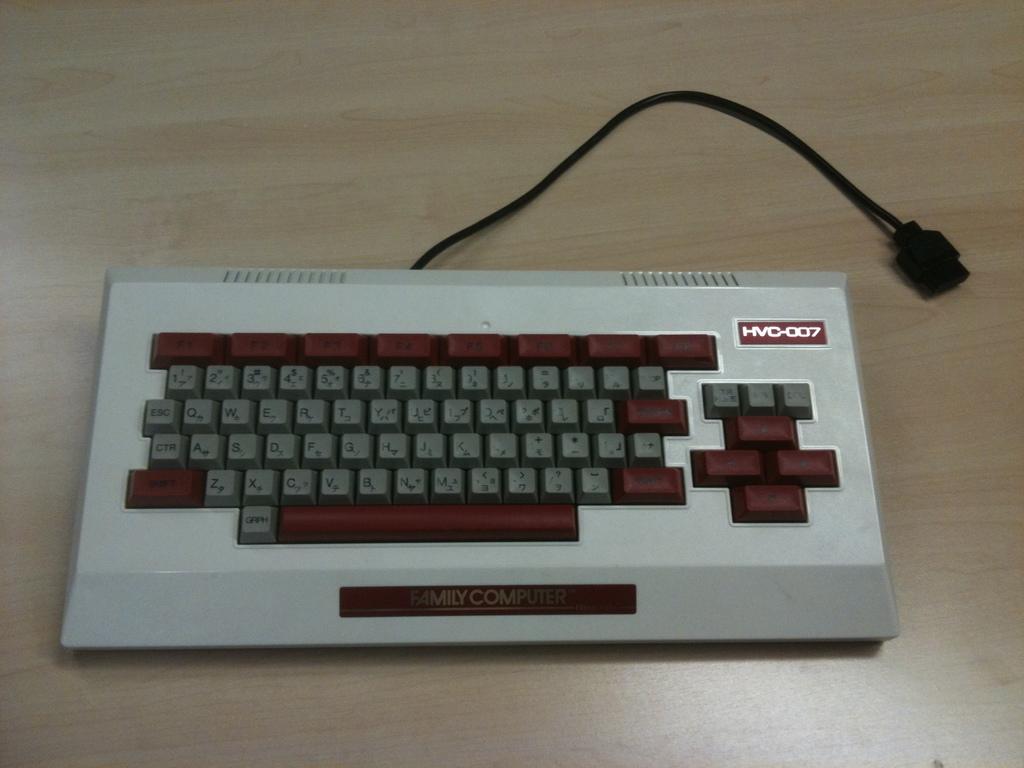What model number is the keyboard?
Provide a short and direct response. Hvc-007. What is the brand of this computer?
Ensure brevity in your answer.  Family computer. 